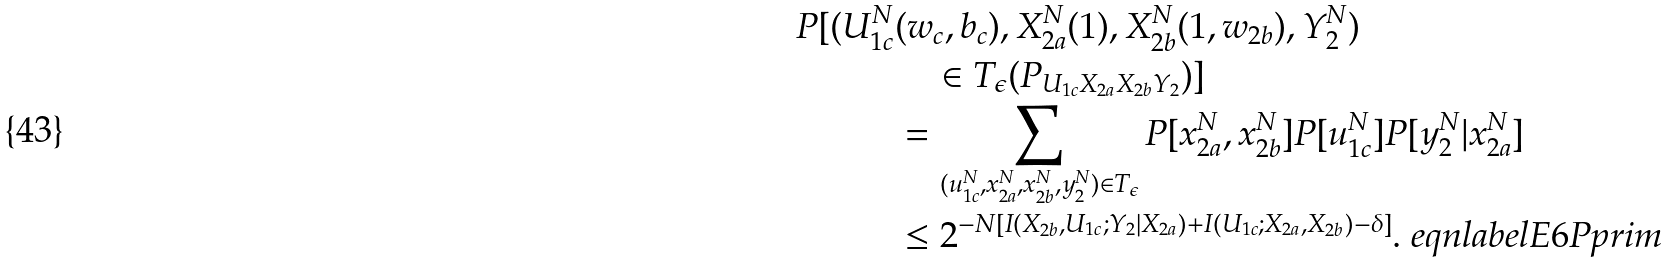Convert formula to latex. <formula><loc_0><loc_0><loc_500><loc_500>P [ ( U _ { 1 c } ^ { N } & ( w _ { c } , b _ { c } ) , X _ { 2 a } ^ { N } ( 1 ) , X _ { 2 b } ^ { N } ( 1 , w _ { 2 b } ) , Y _ { 2 } ^ { N } ) \\ & \quad \in T _ { \epsilon } ( P _ { U _ { 1 c } X _ { 2 a } X _ { 2 b } Y _ { 2 } } ) ] \\ & = \sum _ { ( u _ { 1 c } ^ { N } , x _ { 2 a } ^ { N } , x _ { 2 b } ^ { N } , y _ { 2 } ^ { N } ) \in T _ { \epsilon } } P [ x _ { 2 a } ^ { N } , x _ { 2 b } ^ { N } ] P [ u _ { 1 c } ^ { N } ] P [ y _ { 2 } ^ { N } | x _ { 2 a } ^ { N } ] \\ & \leq 2 ^ { - N [ I ( X _ { 2 b } , U _ { 1 c } ; Y _ { 2 } | X _ { 2 a } ) + I ( U _ { 1 c } ; X _ { 2 a } , X _ { 2 b } ) - \delta ] } . \ e q n l a b e l { E 6 P p r i m }</formula> 